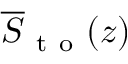<formula> <loc_0><loc_0><loc_500><loc_500>\overline { S } _ { t o } ( z )</formula> 